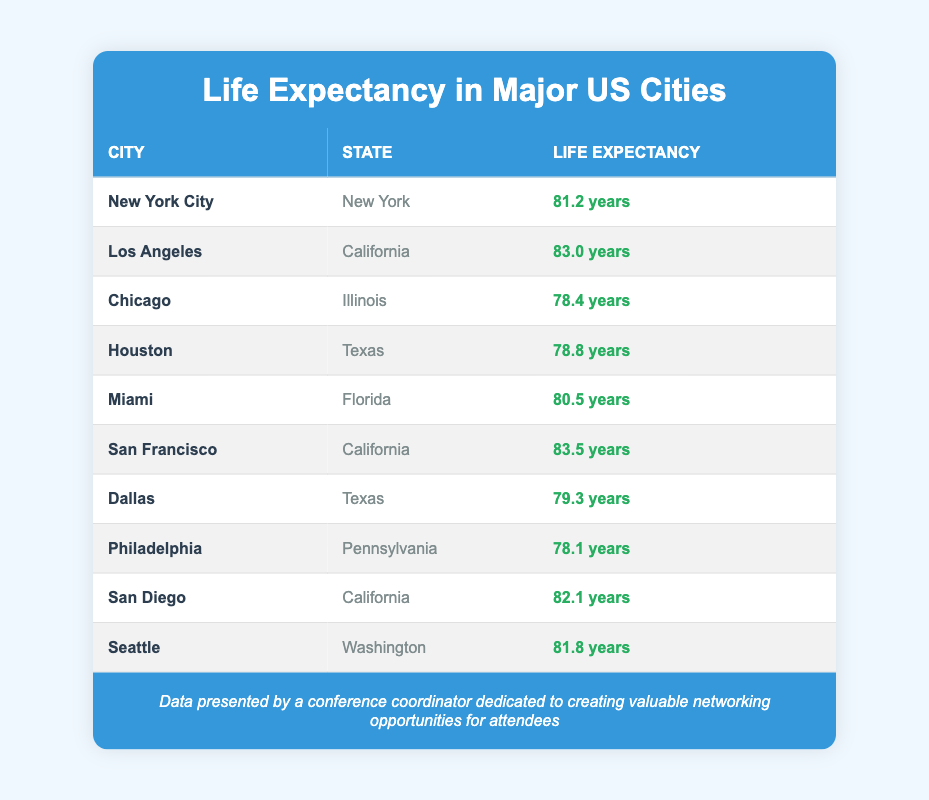What is the life expectancy of San Francisco? San Francisco's life expectancy is specifically listed in the table as 83.5 years.
Answer: 83.5 years Which city has the lowest life expectancy? The lowest life expectancy listed in the table is for Chicago, which is 78.4 years.
Answer: Chicago What is the average life expectancy of the cities in California? The life expectancies for California cities are Los Angeles (83.0), San Francisco (83.5), and San Diego (82.1). Summing these gives 83.0 + 83.5 + 82.1 = 248.6. The average is 248.6 / 3 = 82.87 years.
Answer: 82.87 years Does Seattle have a higher life expectancy than Dallas? Seattle has a life expectancy of 81.8 years, while Dallas has a life expectancy of 79.3 years. Since 81.8 is greater than 79.3, the statement is true.
Answer: Yes What is the difference in life expectancy between New York City and Chicago? New York City's life expectancy is 81.2 years and Chicago's is 78.4 years. To find the difference, we subtract: 81.2 - 78.4 = 2.8 years.
Answer: 2.8 years Is it true that all cities in Texas have a life expectancy greater than 80 years? The cities in Texas listed are Houston (78.8 years) and Dallas (79.3 years). Both are below 80 years, so the statement is false.
Answer: No Which city has a life expectancy that is more than 2 years greater than Philadelphia? Philadelphia’s life expectancy is 78.1 years. We check each city to see if their life expectancy is more than 80.1 years (78.1 + 2). San Francisco (83.5), Los Angeles (83.0), and San Diego (82.1) all exceed this threshold.
Answer: San Francisco, Los Angeles, San Diego 